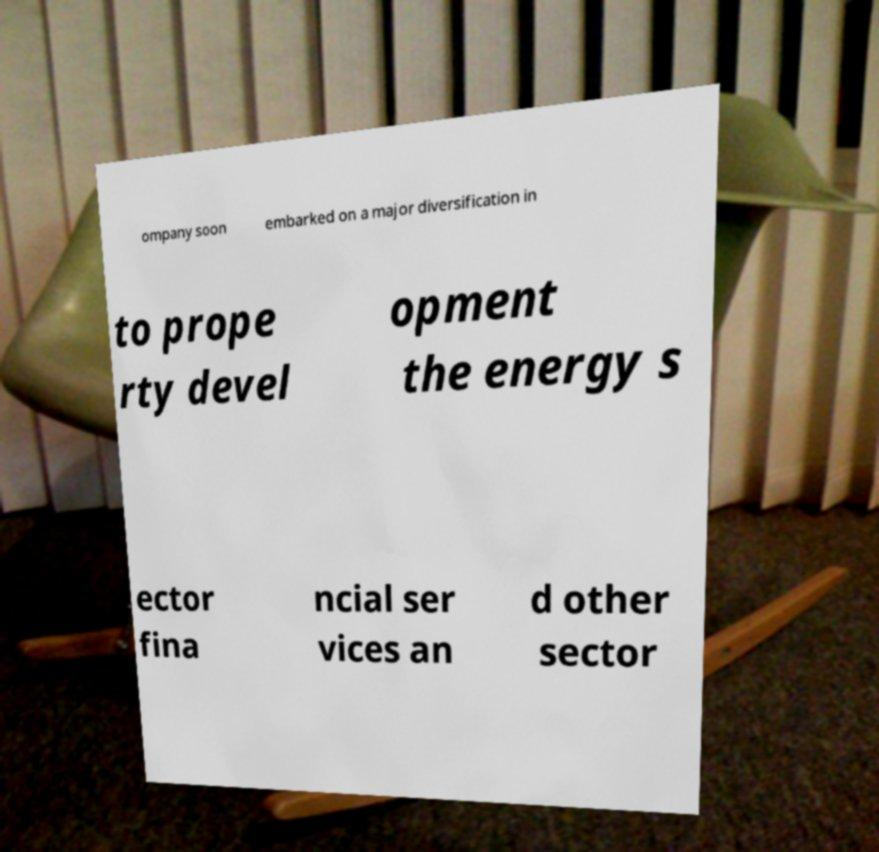Please identify and transcribe the text found in this image. ompany soon embarked on a major diversification in to prope rty devel opment the energy s ector fina ncial ser vices an d other sector 